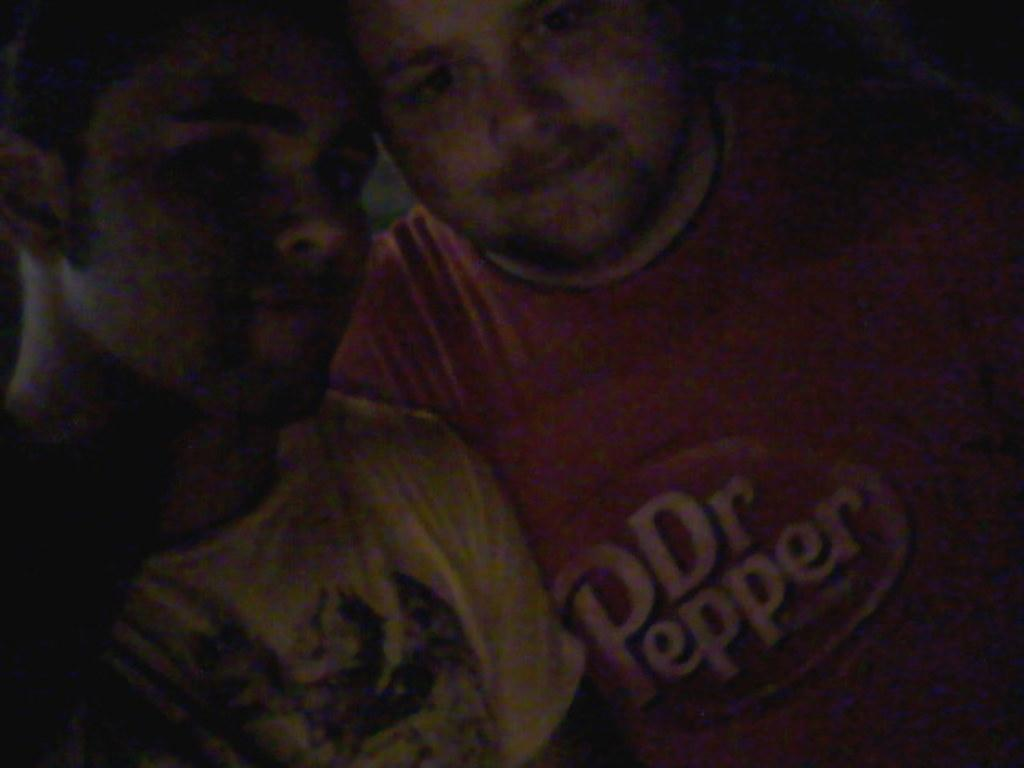How many people are in the image? There are two people in the image. What are the two people doing in the image? The two people are posing for a photo. What type of drum can be seen in the hands of the person on the left? There is no drum present in the image; it only features two people posing for a photo. 